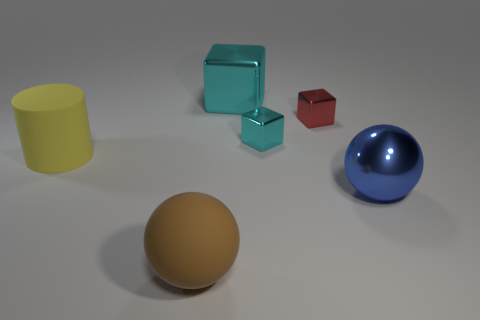Is the shape of the large blue thing the same as the brown matte thing?
Offer a terse response. Yes. What number of other things are the same shape as the blue object?
Give a very brief answer. 1. The other block that is the same size as the red shiny block is what color?
Your response must be concise. Cyan. Are there an equal number of small cyan blocks in front of the tiny cyan shiny block and large cyan metallic cubes?
Offer a very short reply. No. The object that is in front of the large matte cylinder and on the left side of the small red shiny object has what shape?
Keep it short and to the point. Sphere. Is the yellow object the same size as the red object?
Keep it short and to the point. No. Are there any gray cylinders made of the same material as the blue sphere?
Give a very brief answer. No. What is the size of the other cube that is the same color as the large block?
Your answer should be very brief. Small. How many objects are both behind the large metallic sphere and in front of the blue sphere?
Offer a very short reply. 0. There is a big object that is on the left side of the brown object; what is its material?
Keep it short and to the point. Rubber. 